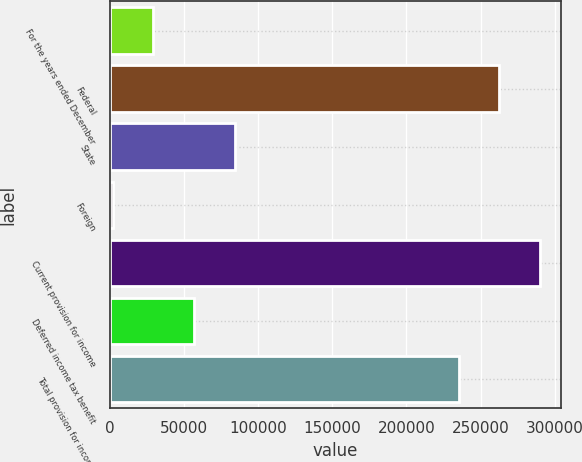<chart> <loc_0><loc_0><loc_500><loc_500><bar_chart><fcel>For the years ended December<fcel>Federal<fcel>State<fcel>Foreign<fcel>Current provision for income<fcel>Deferred income tax benefit<fcel>Total provision for income<nl><fcel>29167.2<fcel>262531<fcel>83955.6<fcel>1773<fcel>289925<fcel>56561.4<fcel>235137<nl></chart> 